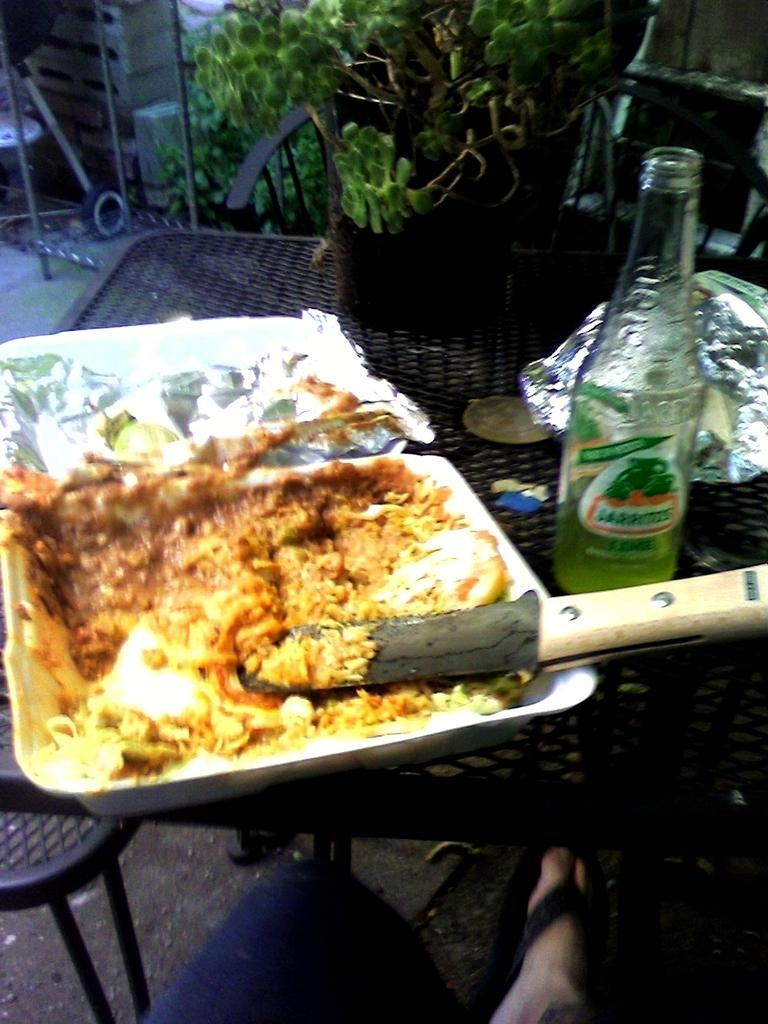What is on the plate in the image? There is a plate with leftover food in the image. What else can be seen on the table besides the plate? There is a bottle and packing covers visible on the table. What is the purpose of the packing covers? The packing covers are likely used to protect the items on the table. What question is the maid asking in the image? There is no maid present in the image, and therefore no question being asked. Is there a turkey on the table in the image? There is no turkey visible in the image. 